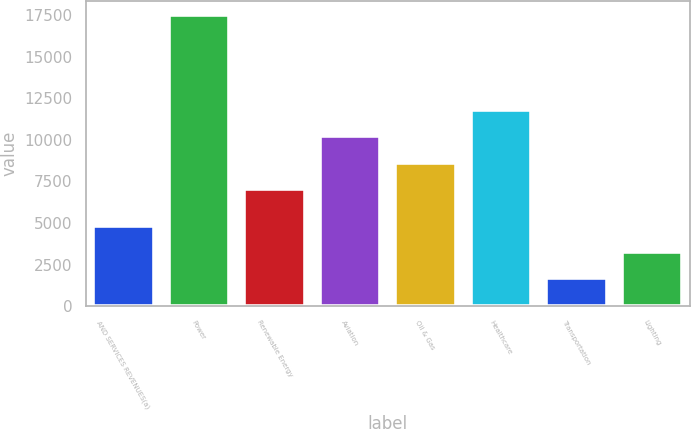<chart> <loc_0><loc_0><loc_500><loc_500><bar_chart><fcel>AND SERVICES REVENUES(a)<fcel>Power<fcel>Renewable Energy<fcel>Aviation<fcel>Oil & Gas<fcel>Healthcare<fcel>Transportation<fcel>Lighting<nl><fcel>4844.2<fcel>17477<fcel>7036<fcel>10215<fcel>8615.1<fcel>11794.1<fcel>1686<fcel>3265.1<nl></chart> 